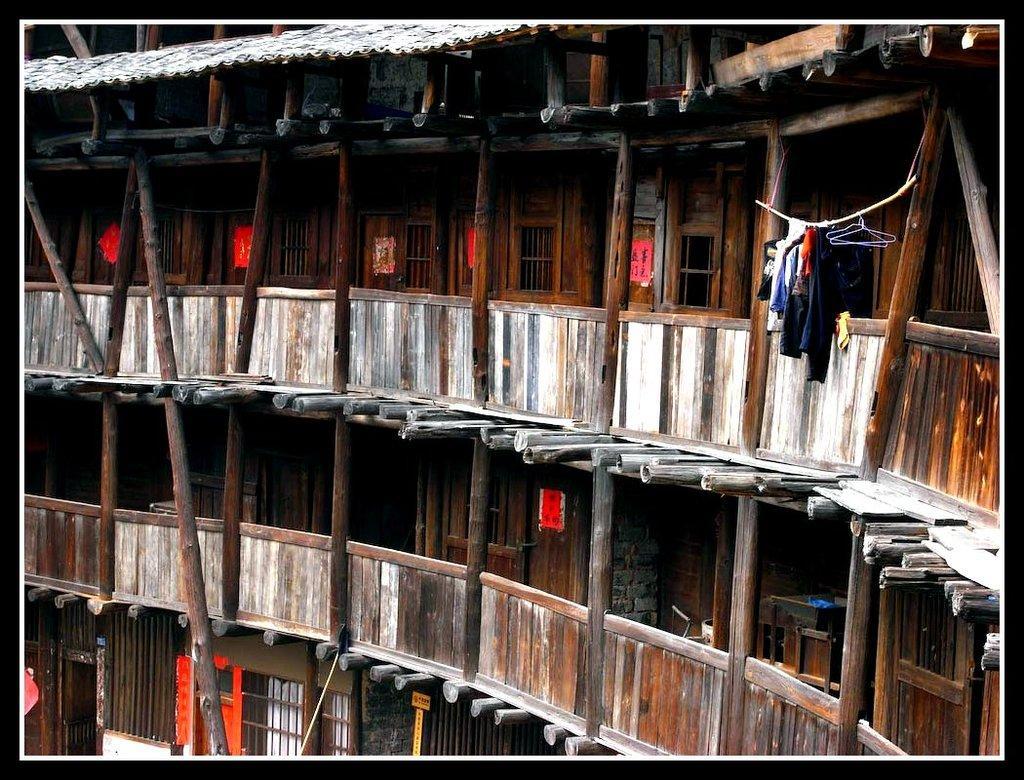Please provide a concise description of this image. In this image I can see a building and I can see a rope attached to the beam of the building, on the rope I can see clothes. 